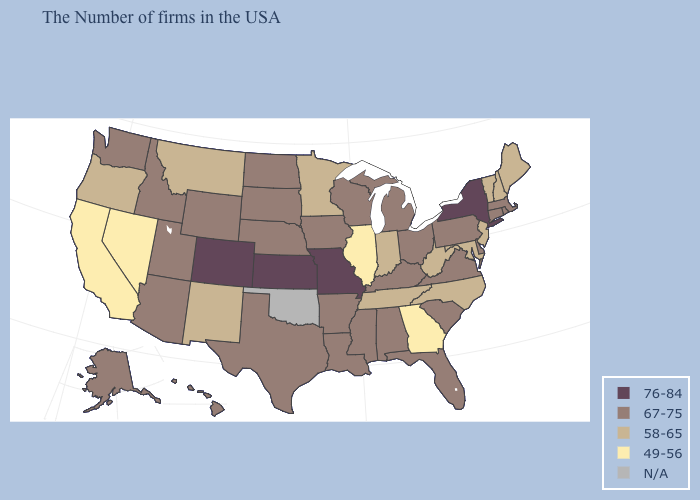Name the states that have a value in the range 76-84?
Be succinct. New York, Missouri, Kansas, Colorado. What is the value of Colorado?
Short answer required. 76-84. Name the states that have a value in the range 49-56?
Quick response, please. Georgia, Illinois, Nevada, California. What is the lowest value in the MidWest?
Be succinct. 49-56. Which states have the highest value in the USA?
Quick response, please. New York, Missouri, Kansas, Colorado. What is the lowest value in the Northeast?
Answer briefly. 58-65. What is the lowest value in states that border Louisiana?
Quick response, please. 67-75. What is the highest value in the USA?
Concise answer only. 76-84. Name the states that have a value in the range N/A?
Short answer required. Oklahoma. Among the states that border Missouri , does Arkansas have the lowest value?
Give a very brief answer. No. Name the states that have a value in the range 49-56?
Short answer required. Georgia, Illinois, Nevada, California. Among the states that border Missouri , which have the highest value?
Give a very brief answer. Kansas. Does Missouri have the highest value in the MidWest?
Concise answer only. Yes. Does Kansas have the highest value in the USA?
Give a very brief answer. Yes. Does the first symbol in the legend represent the smallest category?
Short answer required. No. 